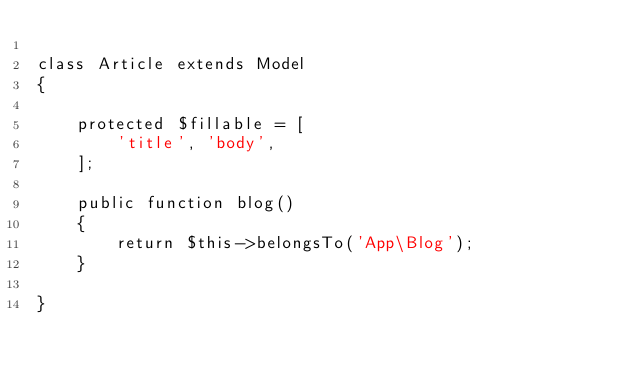Convert code to text. <code><loc_0><loc_0><loc_500><loc_500><_PHP_>
class Article extends Model
{

	protected $fillable = [
        'title', 'body',
    ];

    public function blog()
    {
    	return $this->belongsTo('App\Blog');
    }

}
</code> 